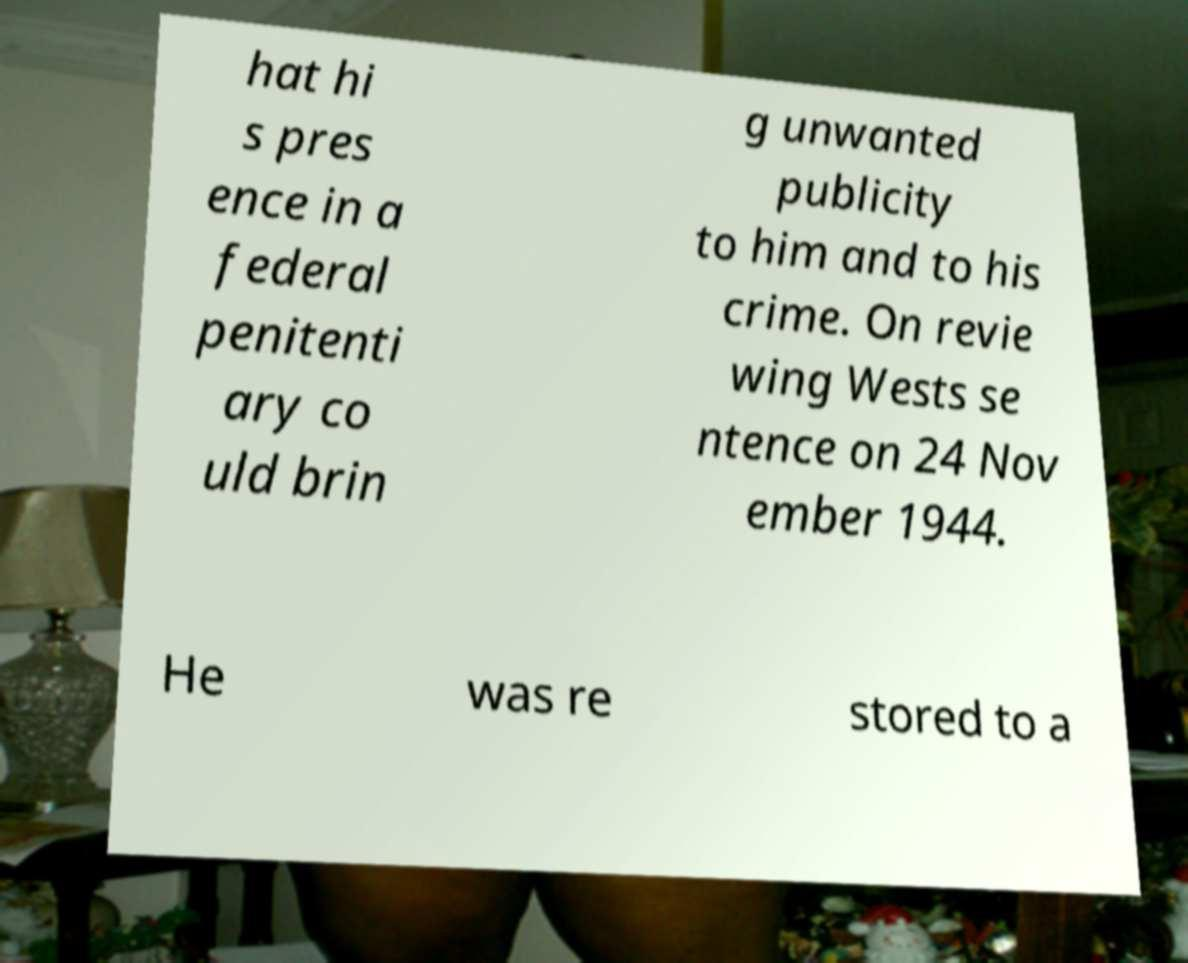Can you accurately transcribe the text from the provided image for me? hat hi s pres ence in a federal penitenti ary co uld brin g unwanted publicity to him and to his crime. On revie wing Wests se ntence on 24 Nov ember 1944. He was re stored to a 